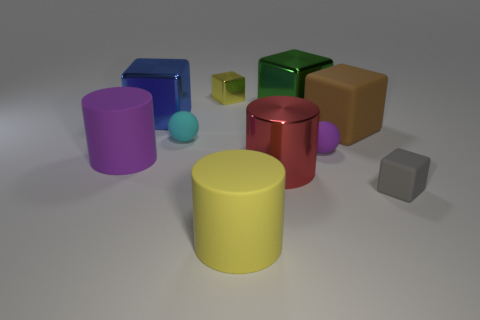Subtract all large blue shiny cubes. How many cubes are left? 4 Subtract all blue cubes. How many cubes are left? 4 Subtract 2 cubes. How many cubes are left? 3 Subtract all cylinders. How many objects are left? 7 Subtract all purple blocks. Subtract all cyan cylinders. How many blocks are left? 5 Add 3 tiny yellow shiny things. How many tiny yellow shiny things are left? 4 Add 7 gray blocks. How many gray blocks exist? 8 Subtract 0 green balls. How many objects are left? 10 Subtract all tiny purple rubber spheres. Subtract all small cyan rubber things. How many objects are left? 8 